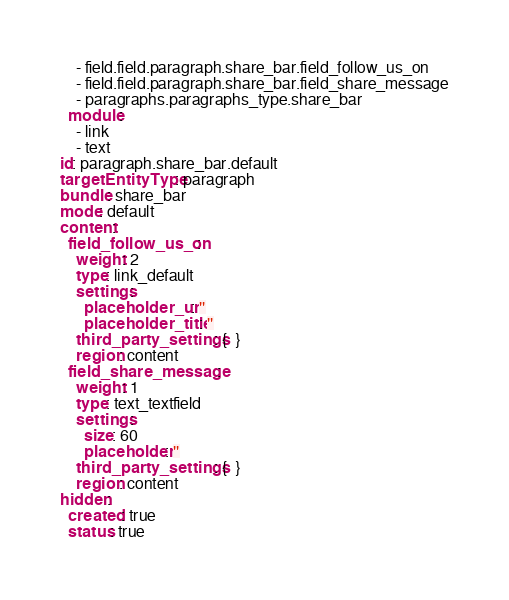<code> <loc_0><loc_0><loc_500><loc_500><_YAML_>    - field.field.paragraph.share_bar.field_follow_us_on
    - field.field.paragraph.share_bar.field_share_message
    - paragraphs.paragraphs_type.share_bar
  module:
    - link
    - text
id: paragraph.share_bar.default
targetEntityType: paragraph
bundle: share_bar
mode: default
content:
  field_follow_us_on:
    weight: 2
    type: link_default
    settings:
      placeholder_url: ''
      placeholder_title: ''
    third_party_settings: {  }
    region: content
  field_share_message:
    weight: 1
    type: text_textfield
    settings:
      size: 60
      placeholder: ''
    third_party_settings: {  }
    region: content
hidden:
  created: true
  status: true
</code> 